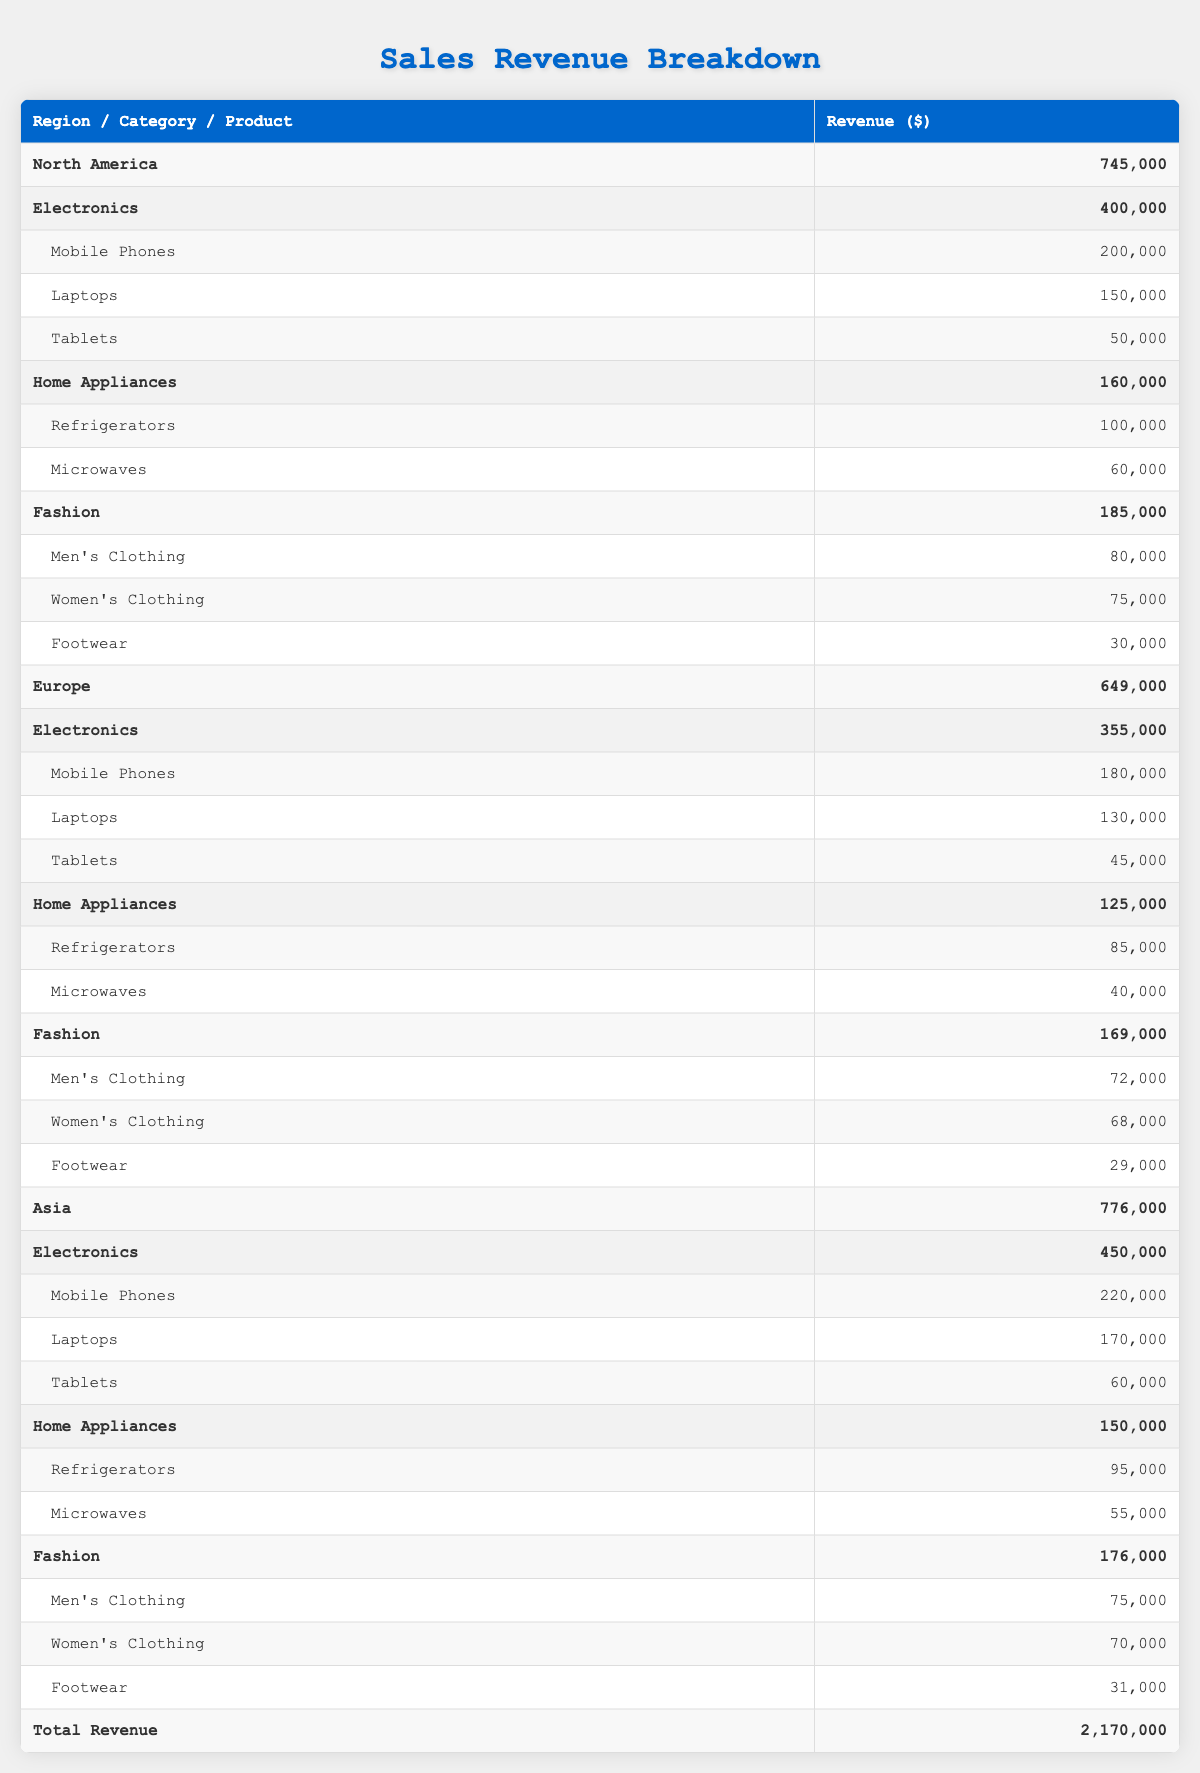What is the total sales revenue for North America? The total sales revenue for North America is calculated by summing the revenue of each category under that region. The categories and their revenues are: Electronics (400,000), Home Appliances (160,000), and Fashion (185,000). Adding these gives us 400,000 + 160,000 + 185,000 = 745,000.
Answer: 745,000 Which product category has the highest revenue in Asia? To determine the highest revenue category in Asia, we can compare the total revenues from each category: Electronics (450,000), Home Appliances (150,000), and Fashion (176,000). The highest is Electronics at 450,000.
Answer: Electronics Is the revenue from Men's Clothing higher in North America than in Europe? The revenue for Men's Clothing in North America is 80,000, while in Europe it is 72,000. Since 80,000 is greater than 72,000, we conclude that the revenue from Men's Clothing in North America is indeed higher than in Europe.
Answer: Yes What is the average revenue for Fashion products across all regions? To find the average revenue for Fashion products, we first sum the revenues from each region: North America (185,000), Europe (169,000), and Asia (176,000). The total is 185,000 + 169,000 + 176,000 = 530,000. Since there are three regions, the average is 530,000 / 3 = 176,667.
Answer: 176,667 Does North America have a higher total revenue compared to Europe? The total revenue for North America is 745,000 and for Europe it is 649,000. Since 745,000 is greater than 649,000, the answer is yes.
Answer: Yes What is the difference in revenue for Mobile Phones between Asia and Europe? To find the difference, we subtract the revenue for Mobile Phones in Europe (180,000) from that in Asia (220,000). Thus, the difference is 220,000 - 180,000 = 40,000.
Answer: 40,000 Which region has the highest total sales revenue? The total sales revenues by region are as follows: North America (745,000), Europe (649,000), and Asia (776,000). Asia has the highest total revenue, which is 776,000.
Answer: Asia What is the combined revenue of Tablets across all regions? The revenue for Tablets is recorded as follows: North America (50,000), Europe (45,000), and Asia (60,000). Adding these, we get 50,000 + 45,000 + 60,000 = 155,000 as the combined revenue for Tablets across all regions.
Answer: 155,000 